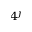Convert formula to latex. <formula><loc_0><loc_0><loc_500><loc_500>4 ^ { j }</formula> 